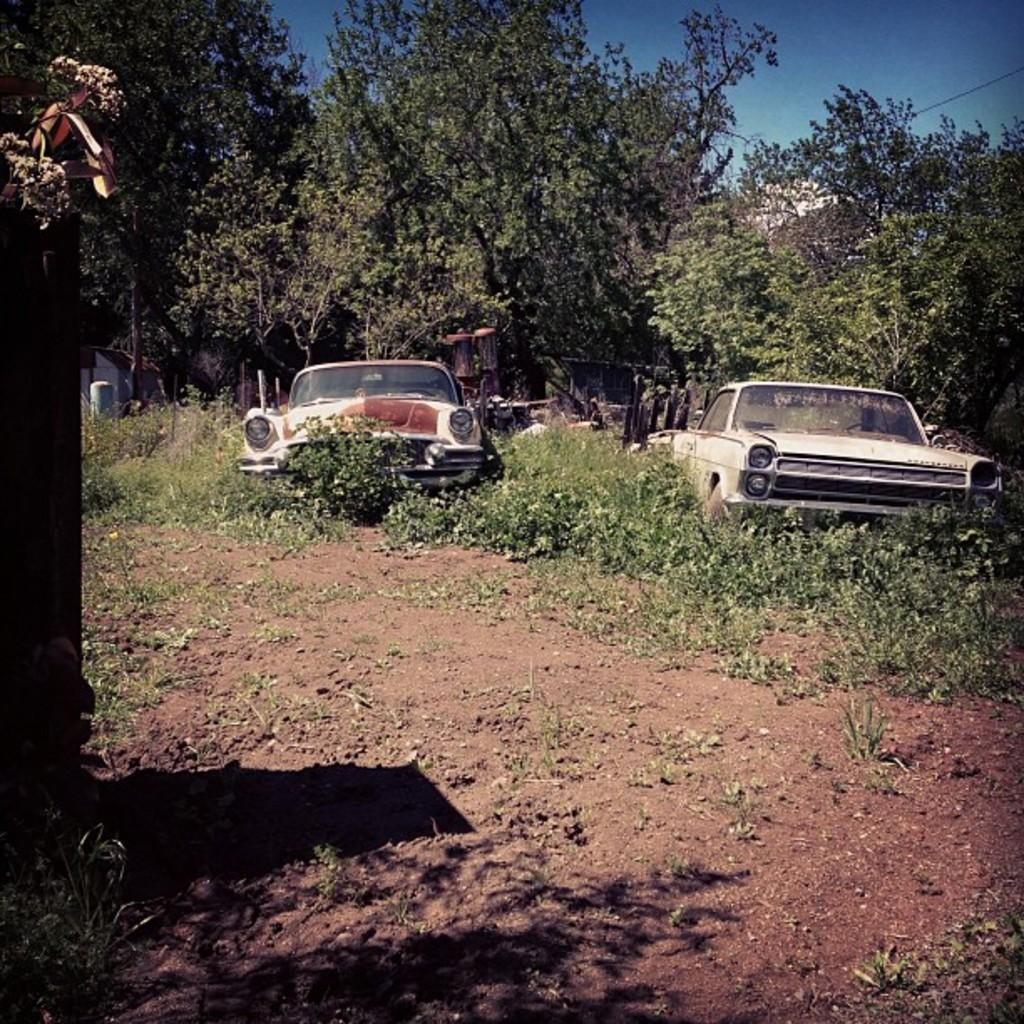What type of vehicles are on the grass in the image? There are two cars on the grass in the image. What can be seen on the path in the image? There are plants on the path in the image. What is visible in the background of the image? There are trees in the background of the image. What color is the sky in the image? The sky is blue in color in the image. Where is the throne located in the image? There is no throne present in the image. What is the number of army soldiers visible in the image? There are no army soldiers present in the image. 